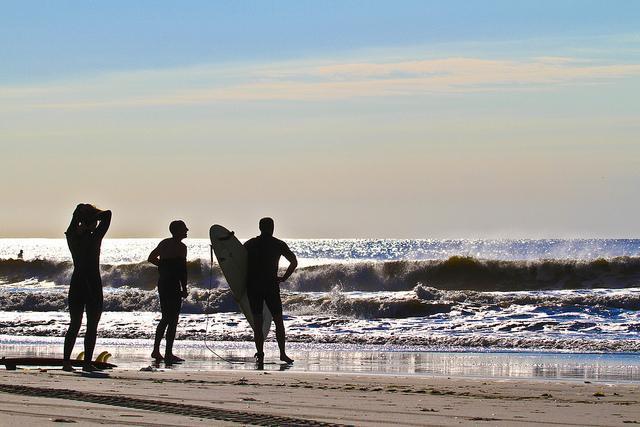How many people are there?
Give a very brief answer. 3. 